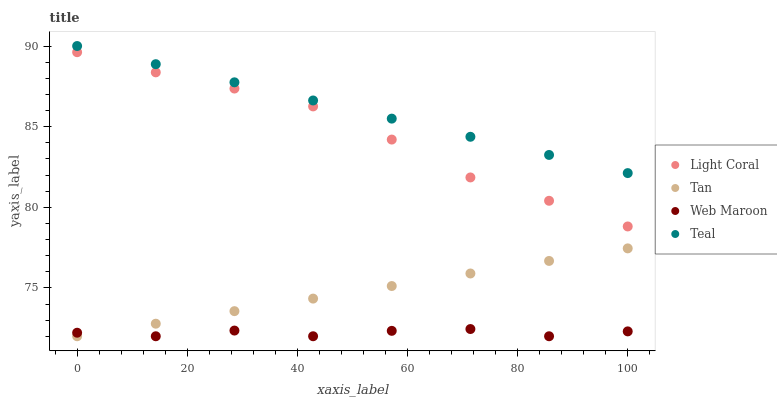Does Web Maroon have the minimum area under the curve?
Answer yes or no. Yes. Does Teal have the maximum area under the curve?
Answer yes or no. Yes. Does Tan have the minimum area under the curve?
Answer yes or no. No. Does Tan have the maximum area under the curve?
Answer yes or no. No. Is Tan the smoothest?
Answer yes or no. Yes. Is Web Maroon the roughest?
Answer yes or no. Yes. Is Web Maroon the smoothest?
Answer yes or no. No. Is Tan the roughest?
Answer yes or no. No. Does Tan have the lowest value?
Answer yes or no. Yes. Does Teal have the lowest value?
Answer yes or no. No. Does Teal have the highest value?
Answer yes or no. Yes. Does Tan have the highest value?
Answer yes or no. No. Is Tan less than Light Coral?
Answer yes or no. Yes. Is Light Coral greater than Web Maroon?
Answer yes or no. Yes. Does Web Maroon intersect Tan?
Answer yes or no. Yes. Is Web Maroon less than Tan?
Answer yes or no. No. Is Web Maroon greater than Tan?
Answer yes or no. No. Does Tan intersect Light Coral?
Answer yes or no. No. 